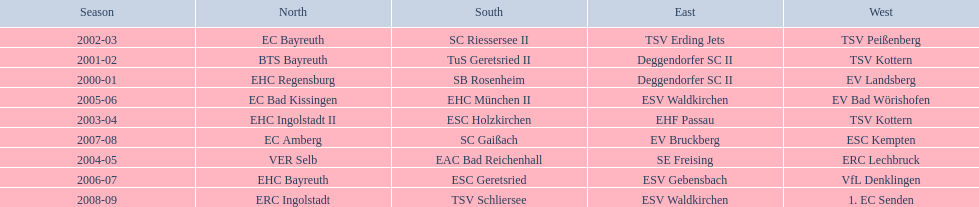Which teams won the north in their respective years? 2000-01, EHC Regensburg, BTS Bayreuth, EC Bayreuth, EHC Ingolstadt II, VER Selb, EC Bad Kissingen, EHC Bayreuth, EC Amberg, ERC Ingolstadt. Which one only won in 2000-01? EHC Regensburg. 